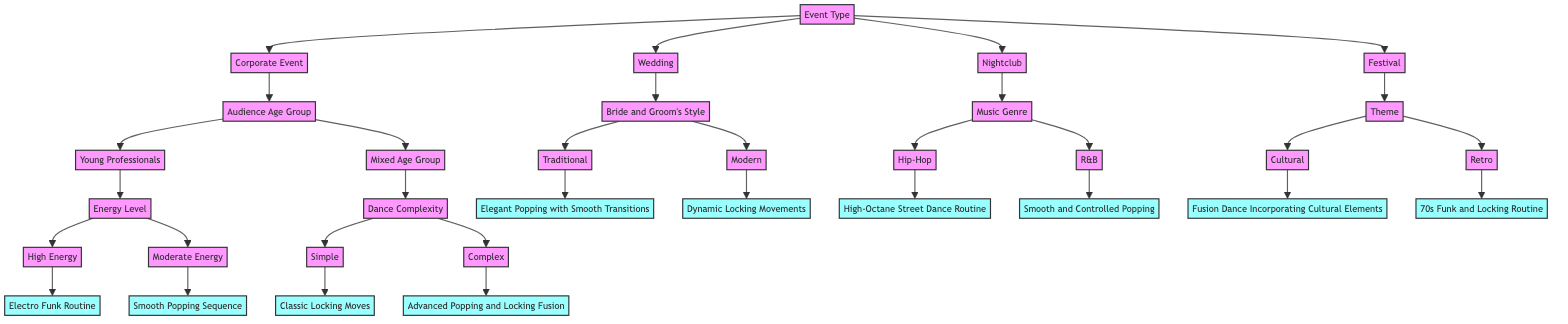What is the first decision node in the diagram? The first decision node in the diagram is "Event Type," which categorizes the various events for which dance routines are chosen.
Answer: Event Type How many options are there under "Event Type"? The "Event Type" node has four options: Corporate Event, Wedding, Nightclub, and Festival, leading to four branches in the diagram.
Answer: Four If the event is a Wedding and the Bride and Groom's Style is Modern, what is the resulting dance routine? Following the Wedding option leads to the Bride and Groom's Style decision. If that style is Modern, the resulting dance routine from the diagram is "Dynamic Locking Movements."
Answer: Dynamic Locking Movements What routine results from a mixed age group audience at a Corporate Event with complex dance requirements? Starting from the Corporate Event to the Mixed Age Group, we then move to Dance Complexity. Since the requirement is complex, the resulting routine is "Advanced Popping and Locking Fusion."
Answer: Advanced Popping and Locking Fusion How many total routines are listed in the diagram? The diagram features ten different routines provided at the end of the branches stemming from various decision paths, accounting for all combinations across the event types, audience characteristics, and style preferences.
Answer: Ten What dance routine is suggested for a High Energy audience at a Nightclub? Starting from the Nightclub option leads us to Music Genre. If the selected genre is hip-hop, the dance routine that corresponds to a High Energy audience is "High-Octane Street Dance Routine."
Answer: High-Octane Street Dance Routine Which dance routine would be suitable for a Cultural-themed Festival? From the Festival option, we move to the Theme decision. Choosing Cultural leads to the routine "Fusion Dance Incorporating Cultural Elements."
Answer: Fusion Dance Incorporating Cultural Elements What is the relationship between "Audience Age Group" and "Dance Complexity"? The relationship shows that the Audience Age Group decision branches into Young Professionals or Mixed Age Group, leading to different subsequent decisions regarding Energy Level and Dance Complexity, respectively.
Answer: Branching decision If the "Event Type" is Nightclub and the "Music Genre" is R&B, what is the recommended dance routine? With the Event Type being Nightclub, we choose R&B as the Music Genre option, which indicates the corresponding dance routine from the diagram is "Smooth and Controlled Popping."
Answer: Smooth and Controlled Popping 